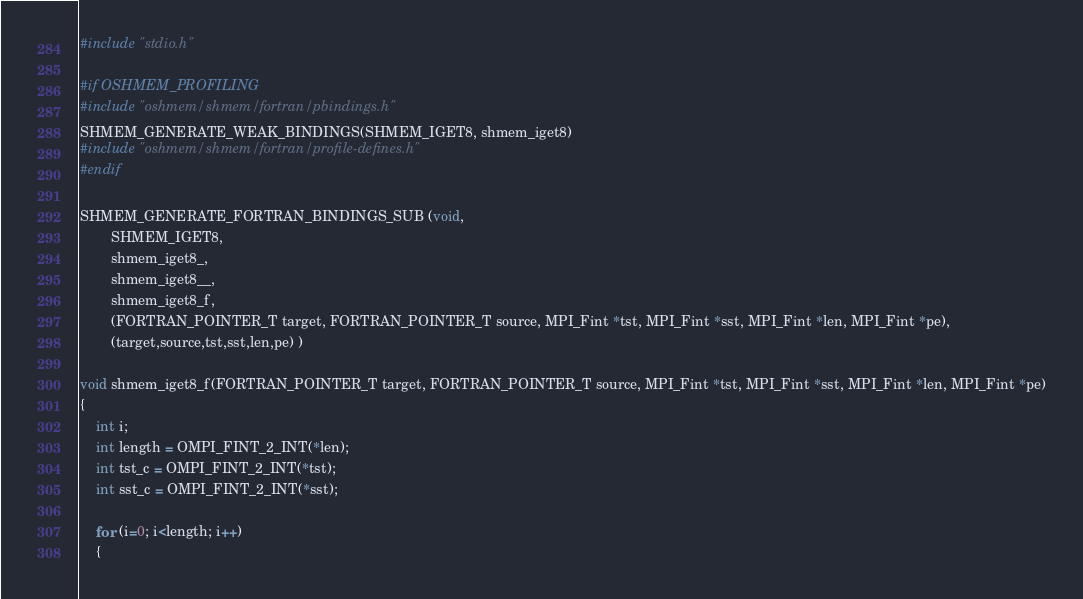<code> <loc_0><loc_0><loc_500><loc_500><_C_>#include "stdio.h"

#if OSHMEM_PROFILING
#include "oshmem/shmem/fortran/pbindings.h"
SHMEM_GENERATE_WEAK_BINDINGS(SHMEM_IGET8, shmem_iget8)
#include "oshmem/shmem/fortran/profile-defines.h"
#endif

SHMEM_GENERATE_FORTRAN_BINDINGS_SUB (void,
        SHMEM_IGET8,
        shmem_iget8_,
        shmem_iget8__,
        shmem_iget8_f,
        (FORTRAN_POINTER_T target, FORTRAN_POINTER_T source, MPI_Fint *tst, MPI_Fint *sst, MPI_Fint *len, MPI_Fint *pe),
        (target,source,tst,sst,len,pe) )

void shmem_iget8_f(FORTRAN_POINTER_T target, FORTRAN_POINTER_T source, MPI_Fint *tst, MPI_Fint *sst, MPI_Fint *len, MPI_Fint *pe)
{
    int i;
    int length = OMPI_FINT_2_INT(*len);
    int tst_c = OMPI_FINT_2_INT(*tst);
    int sst_c = OMPI_FINT_2_INT(*sst);

    for (i=0; i<length; i++)
    {</code> 